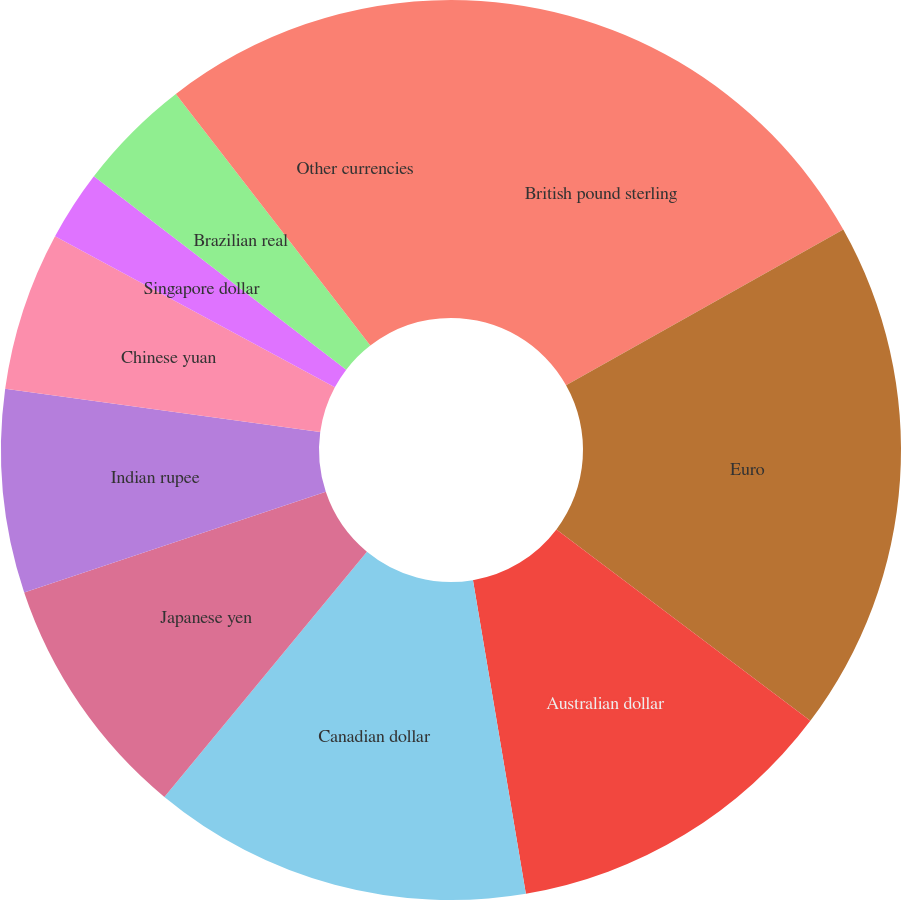Convert chart. <chart><loc_0><loc_0><loc_500><loc_500><pie_chart><fcel>British pound sterling<fcel>Euro<fcel>Australian dollar<fcel>Canadian dollar<fcel>Japanese yen<fcel>Indian rupee<fcel>Chinese yuan<fcel>Singapore dollar<fcel>Brazilian real<fcel>Other currencies<nl><fcel>16.85%<fcel>18.43%<fcel>12.06%<fcel>13.65%<fcel>8.88%<fcel>7.3%<fcel>5.71%<fcel>2.53%<fcel>4.12%<fcel>10.47%<nl></chart> 